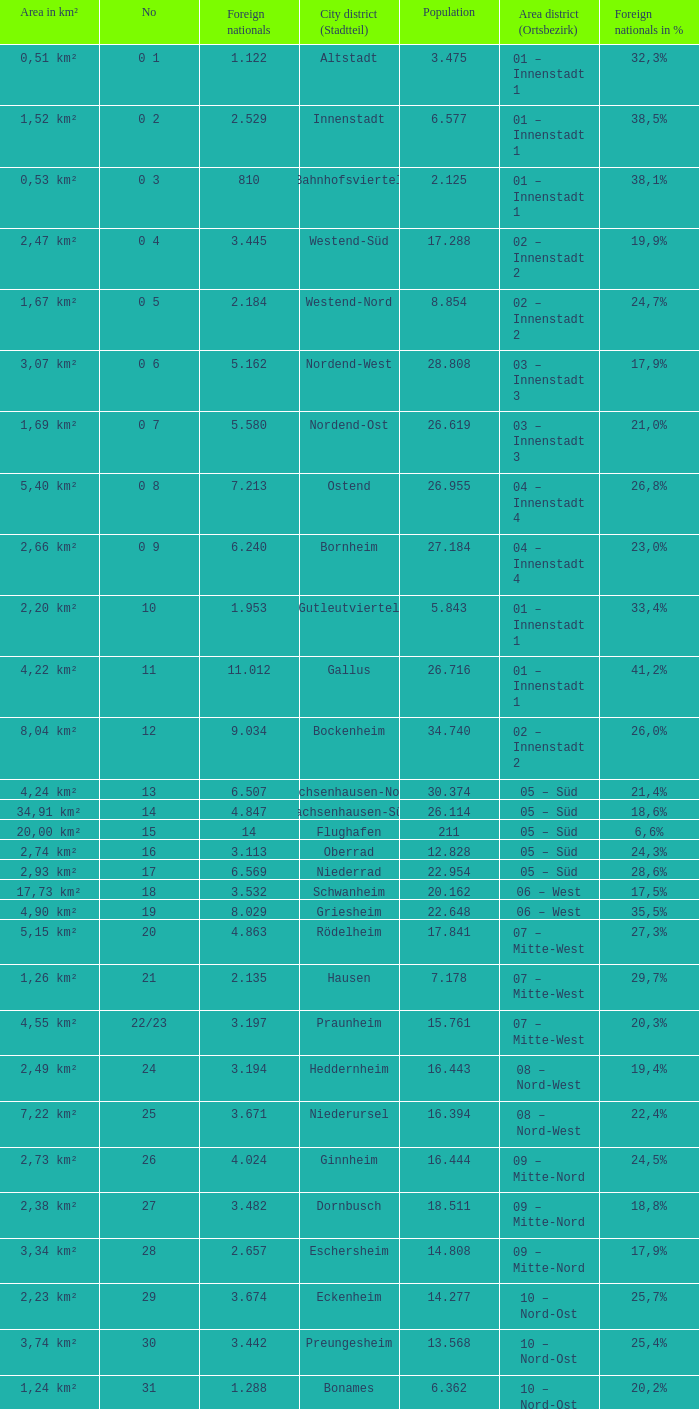What is the city where the number is 47? Frankfurter Berg. 